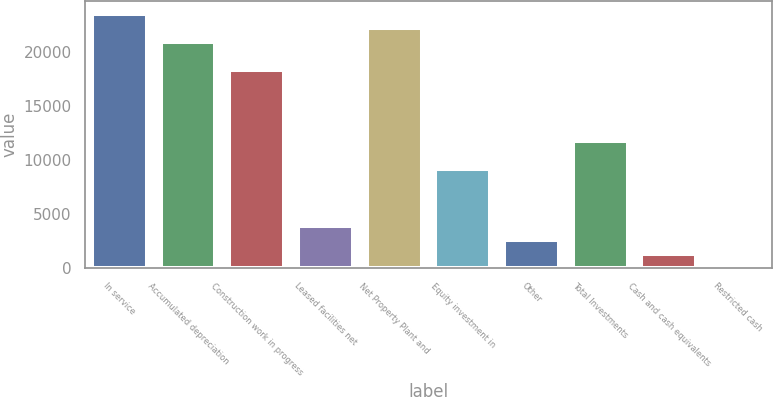Convert chart. <chart><loc_0><loc_0><loc_500><loc_500><bar_chart><fcel>In service<fcel>Accumulated depreciation<fcel>Construction work in progress<fcel>Leased facilities net<fcel>Net Property Plant and<fcel>Equity investment in<fcel>Other<fcel>Total Investments<fcel>Cash and cash equivalents<fcel>Restricted cash<nl><fcel>23501<fcel>20890.7<fcel>18280.4<fcel>3923.75<fcel>22195.8<fcel>9144.35<fcel>2618.6<fcel>11754.6<fcel>1313.45<fcel>8.3<nl></chart> 